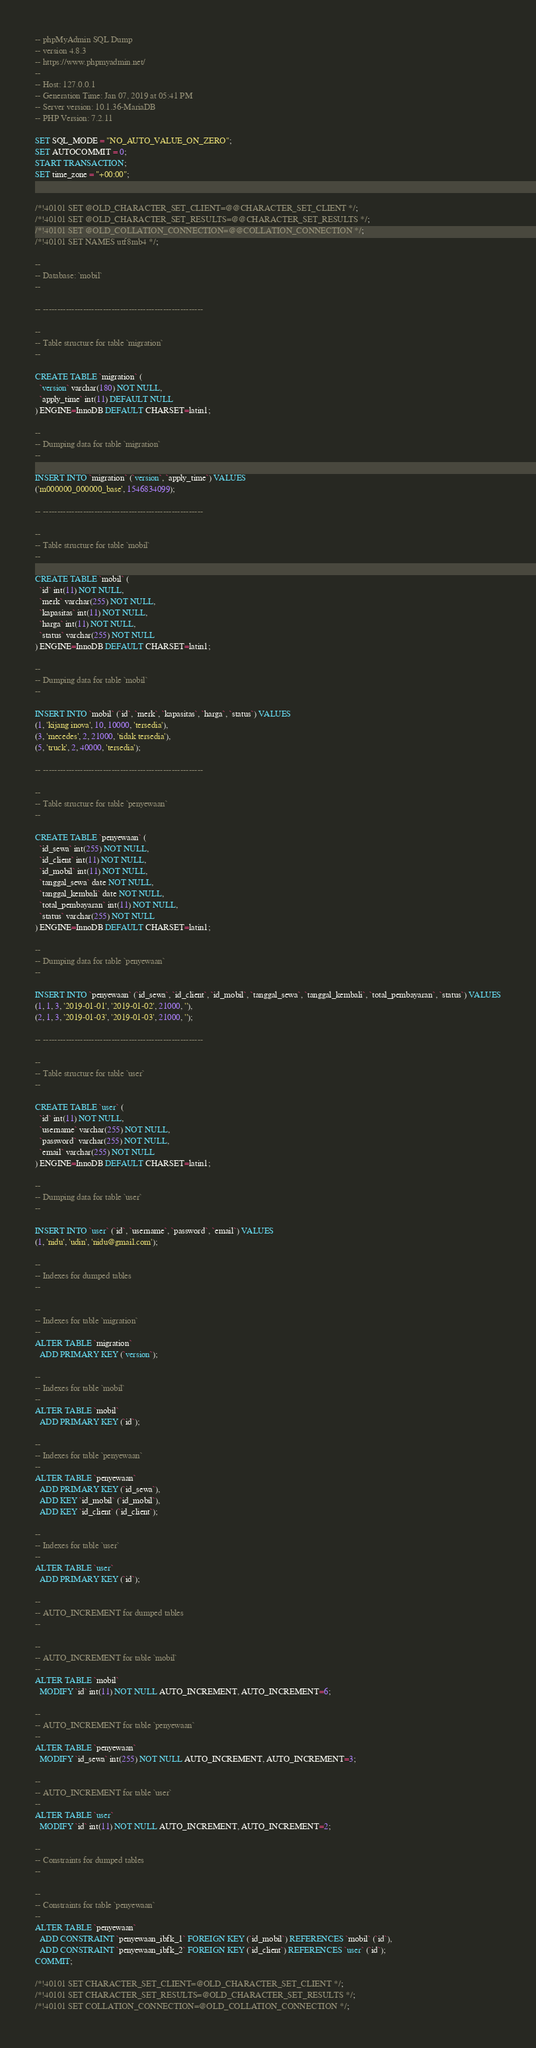Convert code to text. <code><loc_0><loc_0><loc_500><loc_500><_SQL_>-- phpMyAdmin SQL Dump
-- version 4.8.3
-- https://www.phpmyadmin.net/
--
-- Host: 127.0.0.1
-- Generation Time: Jan 07, 2019 at 05:41 PM
-- Server version: 10.1.36-MariaDB
-- PHP Version: 7.2.11

SET SQL_MODE = "NO_AUTO_VALUE_ON_ZERO";
SET AUTOCOMMIT = 0;
START TRANSACTION;
SET time_zone = "+00:00";


/*!40101 SET @OLD_CHARACTER_SET_CLIENT=@@CHARACTER_SET_CLIENT */;
/*!40101 SET @OLD_CHARACTER_SET_RESULTS=@@CHARACTER_SET_RESULTS */;
/*!40101 SET @OLD_COLLATION_CONNECTION=@@COLLATION_CONNECTION */;
/*!40101 SET NAMES utf8mb4 */;

--
-- Database: `mobil`
--

-- --------------------------------------------------------

--
-- Table structure for table `migration`
--

CREATE TABLE `migration` (
  `version` varchar(180) NOT NULL,
  `apply_time` int(11) DEFAULT NULL
) ENGINE=InnoDB DEFAULT CHARSET=latin1;

--
-- Dumping data for table `migration`
--

INSERT INTO `migration` (`version`, `apply_time`) VALUES
('m000000_000000_base', 1546834099);

-- --------------------------------------------------------

--
-- Table structure for table `mobil`
--

CREATE TABLE `mobil` (
  `id` int(11) NOT NULL,
  `merk` varchar(255) NOT NULL,
  `kapasitas` int(11) NOT NULL,
  `harga` int(11) NOT NULL,
  `status` varchar(255) NOT NULL
) ENGINE=InnoDB DEFAULT CHARSET=latin1;

--
-- Dumping data for table `mobil`
--

INSERT INTO `mobil` (`id`, `merk`, `kapasitas`, `harga`, `status`) VALUES
(1, 'kijang inova', 10, 10000, 'tersedia'),
(3, 'mecedes', 2, 21000, 'tidak tersedia'),
(5, 'truck', 2, 40000, 'tersedia');

-- --------------------------------------------------------

--
-- Table structure for table `penyewaan`
--

CREATE TABLE `penyewaan` (
  `id_sewa` int(255) NOT NULL,
  `id_client` int(11) NOT NULL,
  `id_mobil` int(11) NOT NULL,
  `tanggal_sewa` date NOT NULL,
  `tanggal_kembali` date NOT NULL,
  `total_pembayaran` int(11) NOT NULL,
  `status` varchar(255) NOT NULL
) ENGINE=InnoDB DEFAULT CHARSET=latin1;

--
-- Dumping data for table `penyewaan`
--

INSERT INTO `penyewaan` (`id_sewa`, `id_client`, `id_mobil`, `tanggal_sewa`, `tanggal_kembali`, `total_pembayaran`, `status`) VALUES
(1, 1, 3, '2019-01-01', '2019-01-02', 21000, ''),
(2, 1, 3, '2019-01-03', '2019-01-03', 21000, '');

-- --------------------------------------------------------

--
-- Table structure for table `user`
--

CREATE TABLE `user` (
  `id` int(11) NOT NULL,
  `username` varchar(255) NOT NULL,
  `password` varchar(255) NOT NULL,
  `email` varchar(255) NOT NULL
) ENGINE=InnoDB DEFAULT CHARSET=latin1;

--
-- Dumping data for table `user`
--

INSERT INTO `user` (`id`, `username`, `password`, `email`) VALUES
(1, 'nidu', 'udin', 'nidu@gmail.com');

--
-- Indexes for dumped tables
--

--
-- Indexes for table `migration`
--
ALTER TABLE `migration`
  ADD PRIMARY KEY (`version`);

--
-- Indexes for table `mobil`
--
ALTER TABLE `mobil`
  ADD PRIMARY KEY (`id`);

--
-- Indexes for table `penyewaan`
--
ALTER TABLE `penyewaan`
  ADD PRIMARY KEY (`id_sewa`),
  ADD KEY `id_mobil` (`id_mobil`),
  ADD KEY `id_client` (`id_client`);

--
-- Indexes for table `user`
--
ALTER TABLE `user`
  ADD PRIMARY KEY (`id`);

--
-- AUTO_INCREMENT for dumped tables
--

--
-- AUTO_INCREMENT for table `mobil`
--
ALTER TABLE `mobil`
  MODIFY `id` int(11) NOT NULL AUTO_INCREMENT, AUTO_INCREMENT=6;

--
-- AUTO_INCREMENT for table `penyewaan`
--
ALTER TABLE `penyewaan`
  MODIFY `id_sewa` int(255) NOT NULL AUTO_INCREMENT, AUTO_INCREMENT=3;

--
-- AUTO_INCREMENT for table `user`
--
ALTER TABLE `user`
  MODIFY `id` int(11) NOT NULL AUTO_INCREMENT, AUTO_INCREMENT=2;

--
-- Constraints for dumped tables
--

--
-- Constraints for table `penyewaan`
--
ALTER TABLE `penyewaan`
  ADD CONSTRAINT `penyewaan_ibfk_1` FOREIGN KEY (`id_mobil`) REFERENCES `mobil` (`id`),
  ADD CONSTRAINT `penyewaan_ibfk_2` FOREIGN KEY (`id_client`) REFERENCES `user` (`id`);
COMMIT;

/*!40101 SET CHARACTER_SET_CLIENT=@OLD_CHARACTER_SET_CLIENT */;
/*!40101 SET CHARACTER_SET_RESULTS=@OLD_CHARACTER_SET_RESULTS */;
/*!40101 SET COLLATION_CONNECTION=@OLD_COLLATION_CONNECTION */;
</code> 